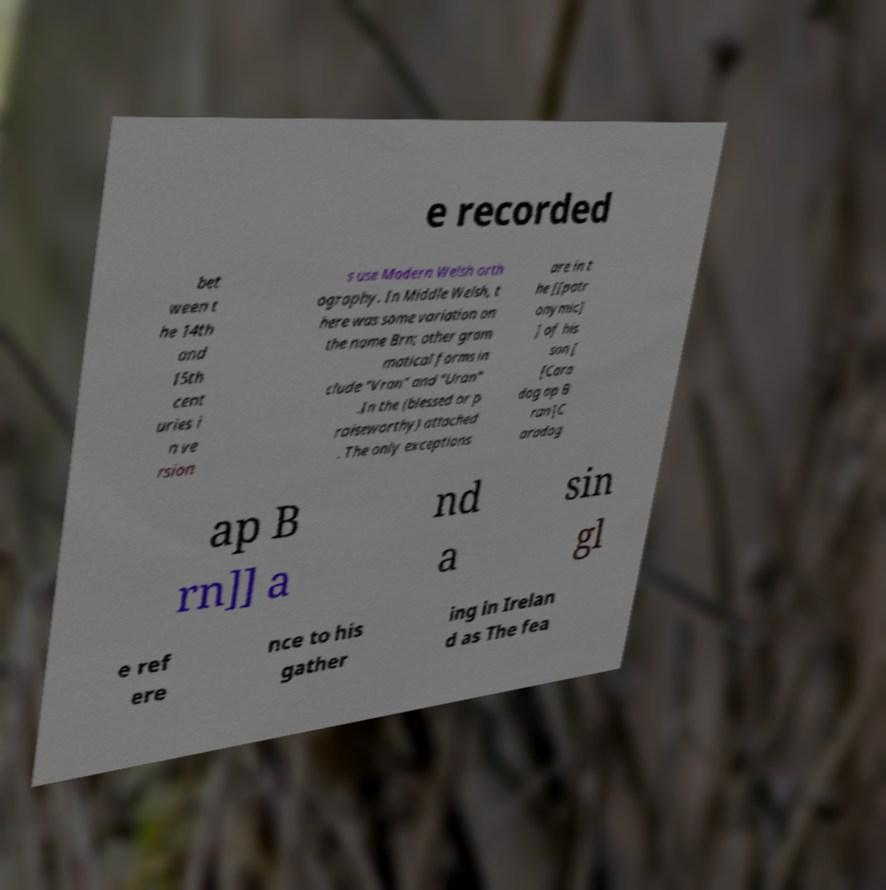There's text embedded in this image that I need extracted. Can you transcribe it verbatim? e recorded bet ween t he 14th and 15th cent uries i n ve rsion s use Modern Welsh orth ography. In Middle Welsh, t here was some variation on the name Brn; other gram matical forms in clude "Vran" and "Uran" .In the (blessed or p raiseworthy) attached . The only exceptions are in t he [[patr onymic] ] of his son [ [Cara dog ap B ran|C aradog ap B rn]] a nd a sin gl e ref ere nce to his gather ing in Irelan d as The fea 